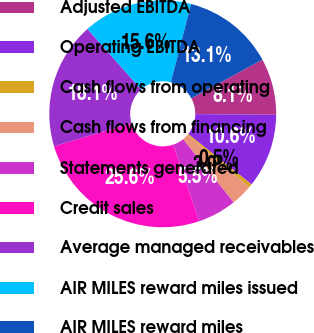<chart> <loc_0><loc_0><loc_500><loc_500><pie_chart><fcel>Adjusted EBITDA<fcel>Operating EBITDA<fcel>Cash flows from operating<fcel>Cash flows from financing<fcel>Statements generated<fcel>Credit sales<fcel>Average managed receivables<fcel>AIR MILES reward miles issued<fcel>AIR MILES reward miles<nl><fcel>8.05%<fcel>10.55%<fcel>0.53%<fcel>3.04%<fcel>5.54%<fcel>25.59%<fcel>18.07%<fcel>15.56%<fcel>13.06%<nl></chart> 